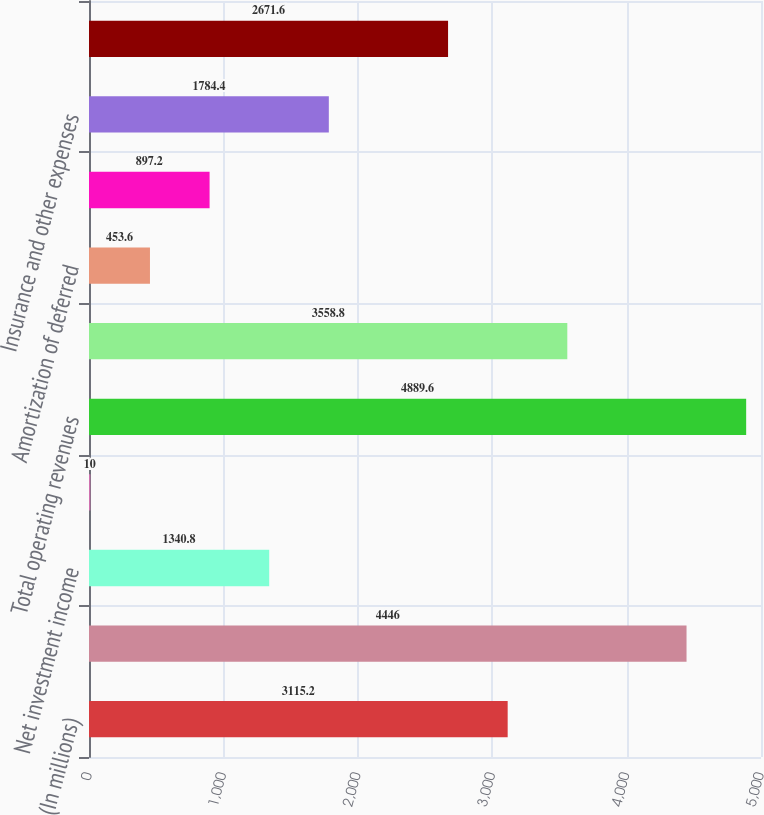Convert chart. <chart><loc_0><loc_0><loc_500><loc_500><bar_chart><fcel>(In millions)<fcel>Premium income<fcel>Net investment income<fcel>Other income<fcel>Total operating revenues<fcel>Benefits and claims<fcel>Amortization of deferred<fcel>Insurance commissions<fcel>Insurance and other expenses<fcel>Total operating expenses<nl><fcel>3115.2<fcel>4446<fcel>1340.8<fcel>10<fcel>4889.6<fcel>3558.8<fcel>453.6<fcel>897.2<fcel>1784.4<fcel>2671.6<nl></chart> 